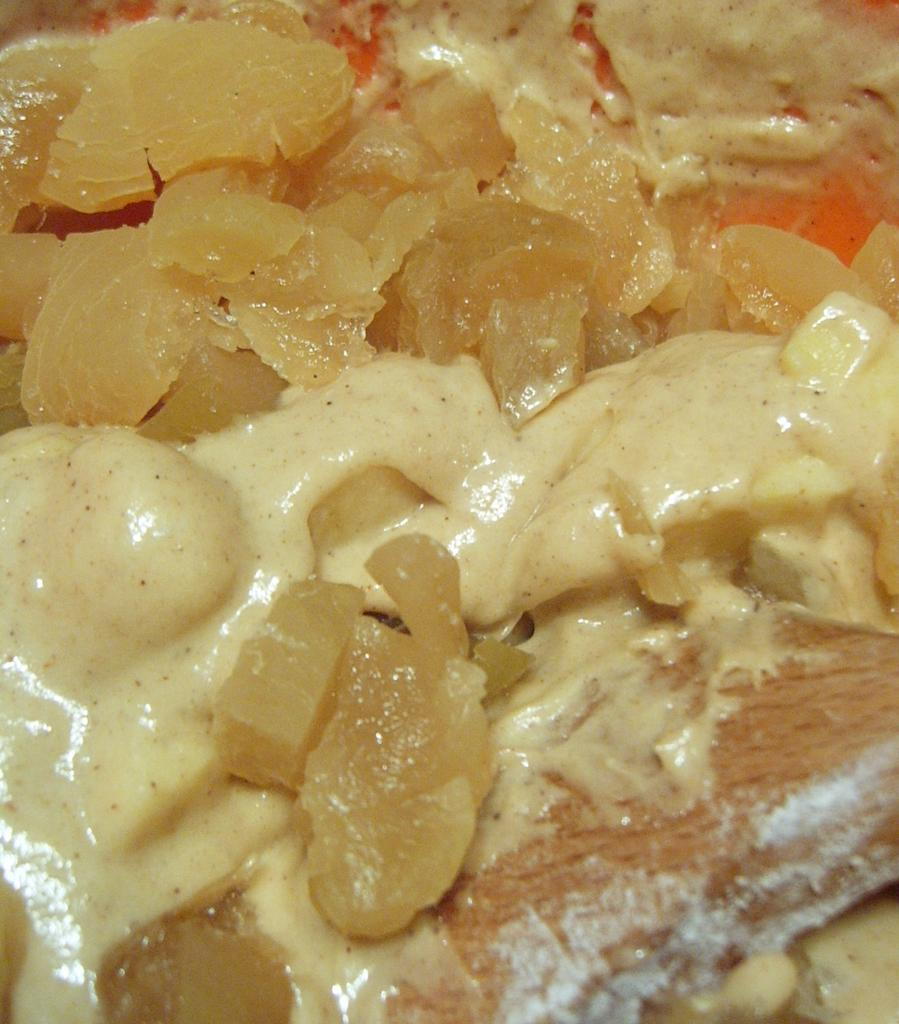What is present in the image? There is food in the image. What type of clouds can be seen in the image? There are no clouds present in the image, as it only features food. What is the rod used for in the image? There is no rod present in the image; it only features food. 